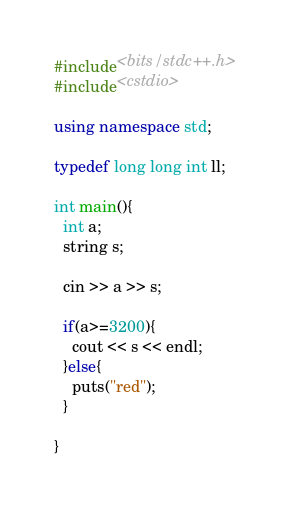<code> <loc_0><loc_0><loc_500><loc_500><_C++_>#include<bits/stdc++.h>
#include<cstdio>

using namespace std;

typedef long long int ll;

int main(){
  int a;
  string s;

  cin >> a >> s;

  if(a>=3200){
  	cout << s << endl;
  }else{
    puts("red");
  }
  
}</code> 